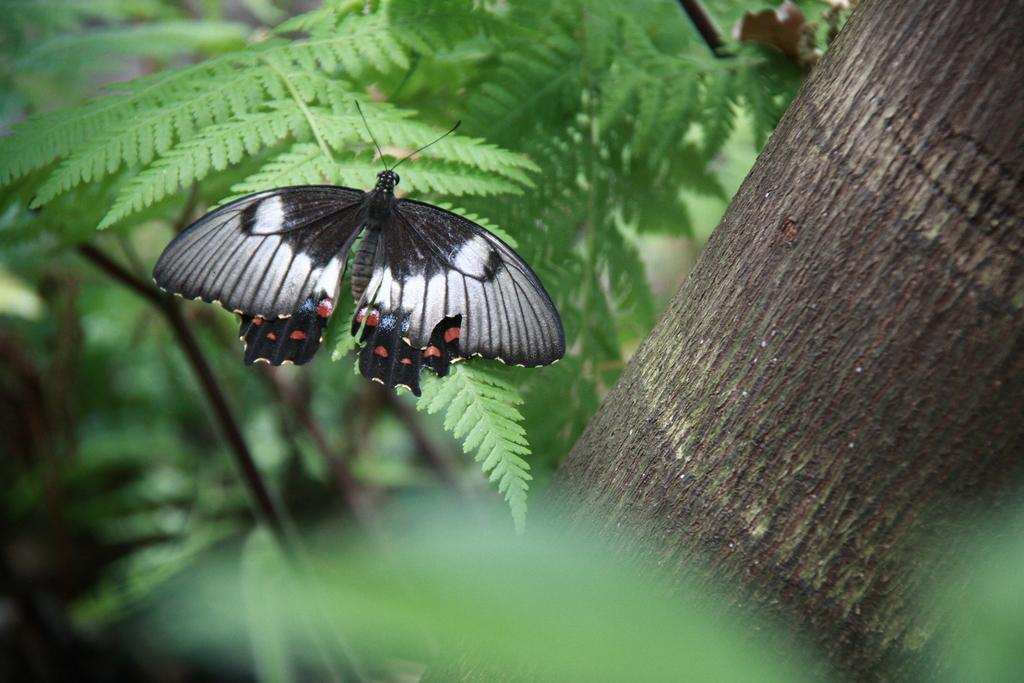What type of animal can be seen in the picture? There is a butterfly in the picture. What natural elements are present in the picture? Leaves and branches are visible in the picture. How many beds are visible in the picture? There are no beds present in the picture; it features a butterfly and natural elements. What type of account is being discussed in the picture? There is no account being discussed in the picture; it features a butterfly and natural elements. 